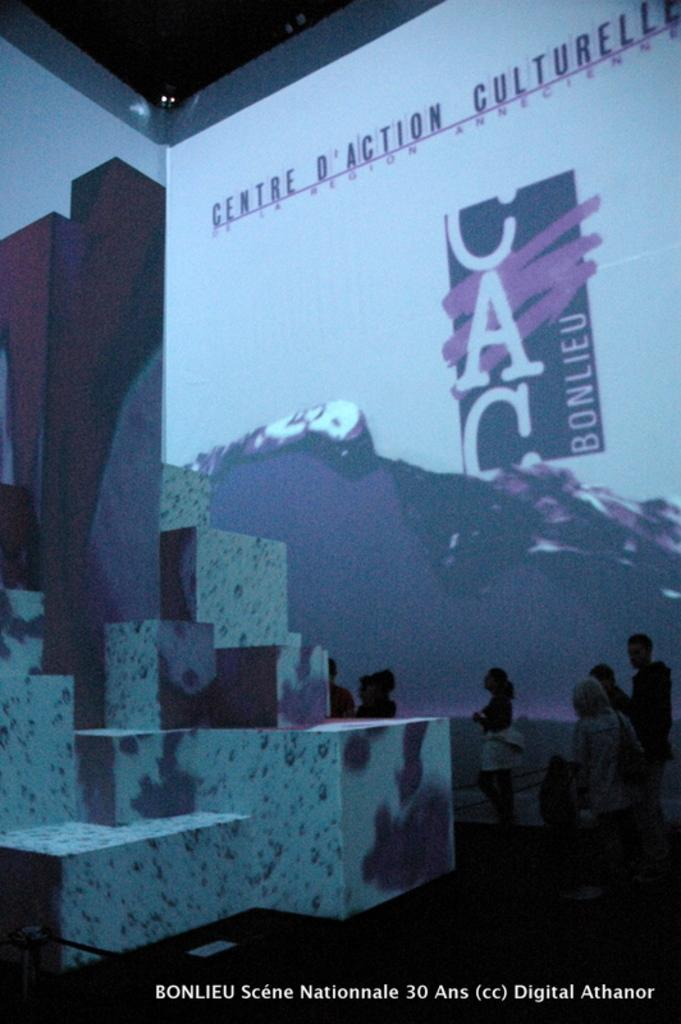How many people are in the image? There are few persons in the image. What can be seen on the screen in the image? The facts do not specify what is on the screen, so we cannot answer that question definitively. What type of surface is present beneath the people and screen? There is a floor in the image. What is above the people and screen in the image? There is a roof in the image. What object is located on the left side of the image? There is a block on the left side of the image. What type of milk is being poured on the wall in the image? There is no milk or wall present in the image. How many balls are visible on the floor in the image? There are no balls present in the image. 